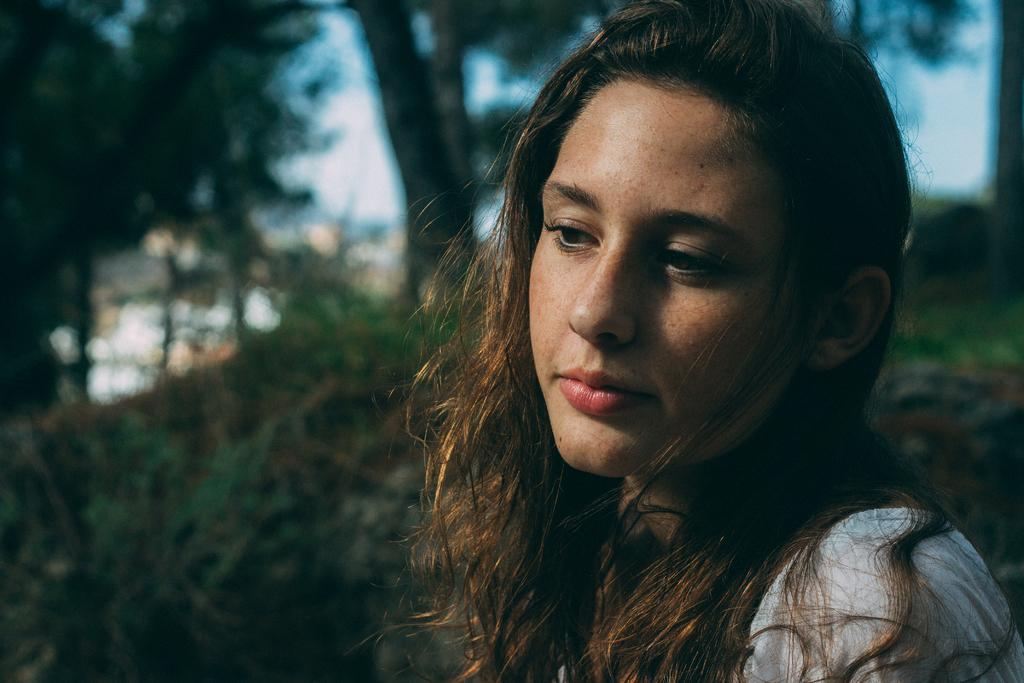What is the main subject in the foreground of the image? There is a woman in the foreground of the image. What can be seen in the background of the image? There are trees in the background of the image. Can you see a goat wearing a bell in the image? There is no goat or bell present in the image. Is there a volcano visible in the background of the image? There is no volcano visible in the image; it features a woman in the foreground and trees in the background. 